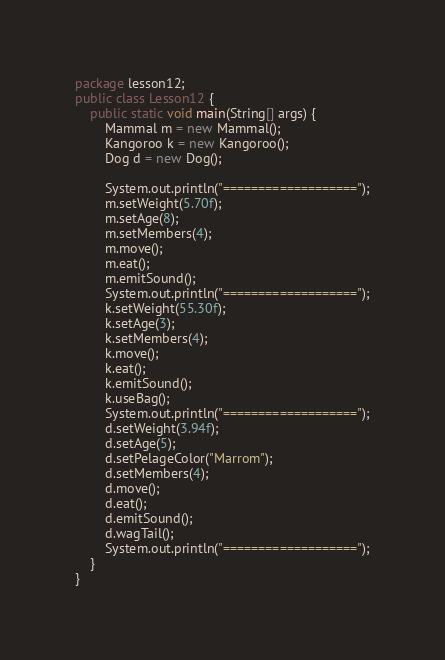Convert code to text. <code><loc_0><loc_0><loc_500><loc_500><_Java_>package lesson12;
public class Lesson12 {
    public static void main(String[] args) {
        Mammal m = new Mammal();
        Kangoroo k = new Kangoroo();
        Dog d = new Dog();
        
        System.out.println("===================");
        m.setWeight(5.70f);
        m.setAge(8);
        m.setMembers(4);
        m.move();
        m.eat();
        m.emitSound();
        System.out.println("===================");
        k.setWeight(55.30f);
        k.setAge(3);
        k.setMembers(4);
        k.move();
        k.eat();
        k.emitSound();
        k.useBag();
        System.out.println("===================");
        d.setWeight(3.94f);
        d.setAge(5);
        d.setPelageColor("Marrom");
        d.setMembers(4);
        d.move();
        d.eat();
        d.emitSound();
        d.wagTail();
        System.out.println("===================");
    }
}
</code> 